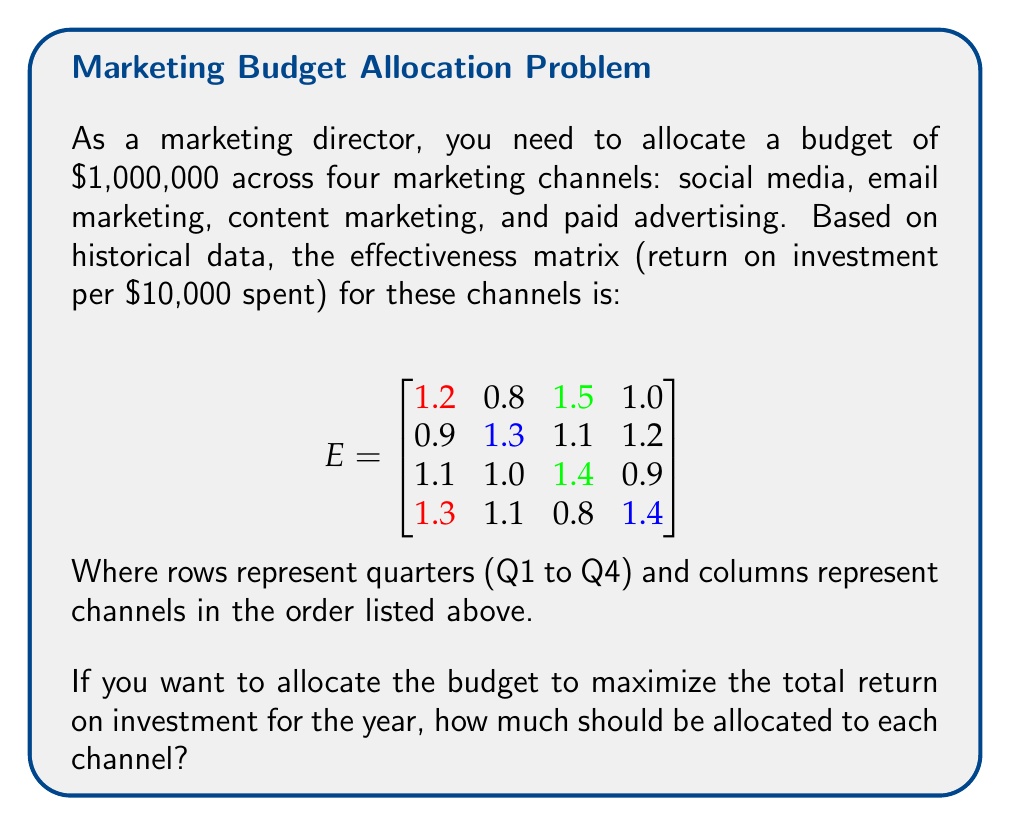Show me your answer to this math problem. To solve this problem, we need to follow these steps:

1) First, we need to calculate the average effectiveness for each channel across all quarters:

   Social Media: $(1.2 + 0.9 + 1.1 + 1.3) / 4 = 1.125$
   Email Marketing: $(0.8 + 1.3 + 1.0 + 1.1) / 4 = 1.05$
   Content Marketing: $(1.5 + 1.1 + 1.4 + 0.8) / 4 = 1.2$
   Paid Advertising: $(1.0 + 1.2 + 0.9 + 1.4) / 4 = 1.125$

2) Now we have the average effectiveness vector:

   $$V = [1.125, 1.05, 1.2, 1.125]$$

3) To maximize ROI, we should allocate the entire budget to the channel with the highest average effectiveness, which is Content Marketing with 1.2.

4) The budget is $1,000,000, so we allocate:

   Content Marketing: $1,000,000
   All other channels: $0

5) This allocation will theoretically yield the highest overall ROI based on the given effectiveness matrix.

Note: In practice, it's often advisable to diversify marketing efforts rather than putting all resources into one channel. This solution is based purely on mathematical optimization of the given data.
Answer: Content Marketing: $1,000,000; Others: $0 